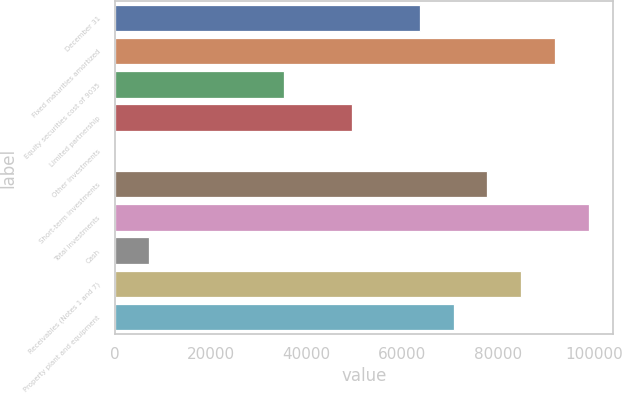Convert chart to OTSL. <chart><loc_0><loc_0><loc_500><loc_500><bar_chart><fcel>December 31<fcel>Fixed maturities amortized<fcel>Equity securities cost of 9035<fcel>Limited partnership<fcel>Other investments<fcel>Short-term investments<fcel>Total investments<fcel>Cash<fcel>Receivables (Notes 1 and 7)<fcel>Property plant and equipment<nl><fcel>63611.2<fcel>91868.7<fcel>35353.8<fcel>49482.5<fcel>32<fcel>77740<fcel>98933<fcel>7096.36<fcel>84804.3<fcel>70675.6<nl></chart> 